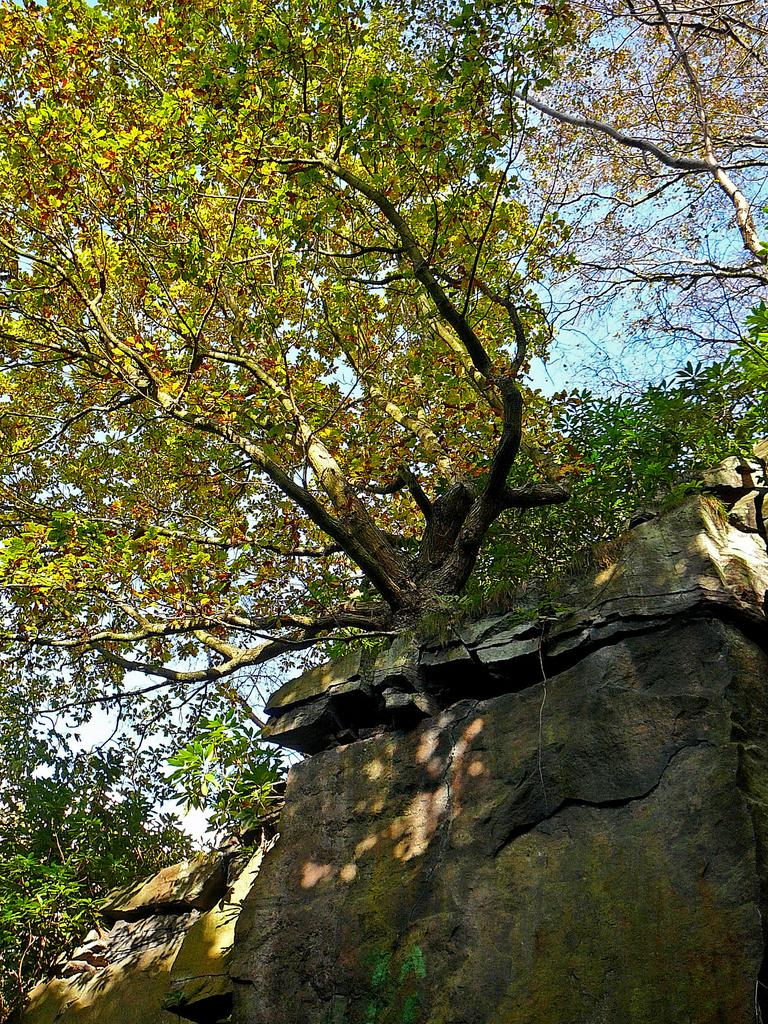What is the main subject of the image? The main subject of the image is a rock. What can be seen on the rock? Trees are visible on the rock. What is visible in the background of the image? The sky is visible behind the rock. Reasoning: Let's think step by following the guidelines to produce the conversation. We start by identifying the main subject of the image, which is the rock. Then, we describe what is on the rock, which are trees. Finally, we mention the background of the image, which is the sky. We ensure that each question can be answered definitively with the information given and avoid yes/no questions. Absurd Question/Answer: What activity is the rock performing in the image? Rocks do not perform activities, as they are inanimate objects. 